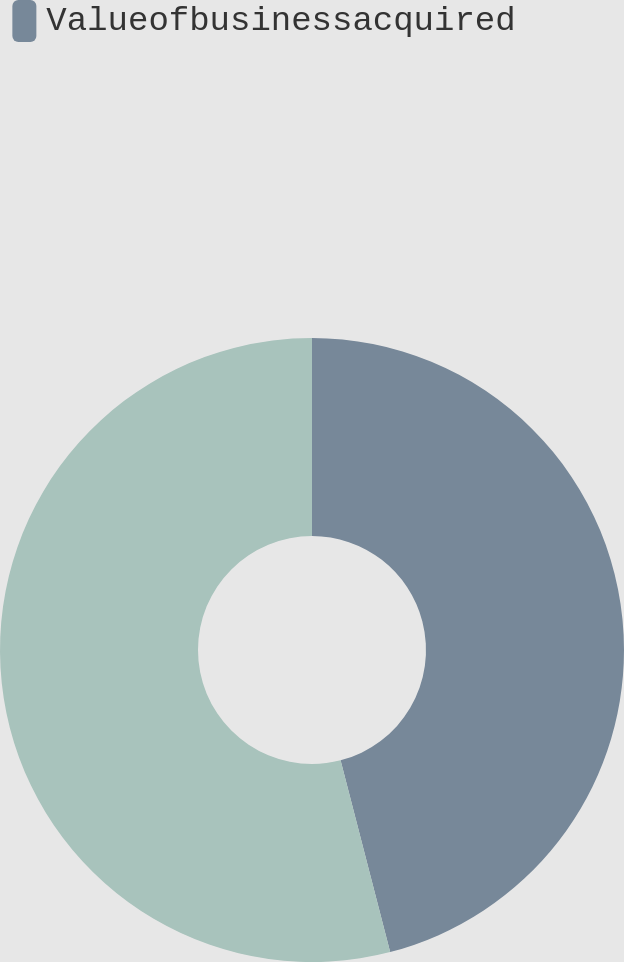<chart> <loc_0><loc_0><loc_500><loc_500><pie_chart><fcel>Valueofbusinessacquired<fcel>Unnamed: 1<nl><fcel>45.97%<fcel>54.03%<nl></chart> 